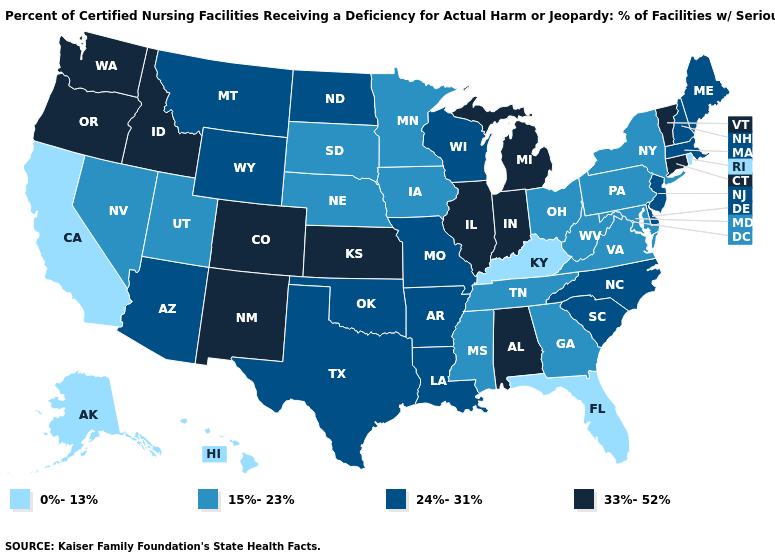What is the highest value in the South ?
Write a very short answer. 33%-52%. Name the states that have a value in the range 15%-23%?
Concise answer only. Georgia, Iowa, Maryland, Minnesota, Mississippi, Nebraska, Nevada, New York, Ohio, Pennsylvania, South Dakota, Tennessee, Utah, Virginia, West Virginia. Name the states that have a value in the range 24%-31%?
Give a very brief answer. Arizona, Arkansas, Delaware, Louisiana, Maine, Massachusetts, Missouri, Montana, New Hampshire, New Jersey, North Carolina, North Dakota, Oklahoma, South Carolina, Texas, Wisconsin, Wyoming. Among the states that border Wyoming , does Idaho have the lowest value?
Give a very brief answer. No. Among the states that border Delaware , does Pennsylvania have the highest value?
Concise answer only. No. What is the highest value in the MidWest ?
Short answer required. 33%-52%. What is the value of Washington?
Answer briefly. 33%-52%. What is the value of New Jersey?
Answer briefly. 24%-31%. What is the value of Kansas?
Concise answer only. 33%-52%. Among the states that border Indiana , does Illinois have the highest value?
Answer briefly. Yes. Does Kentucky have the lowest value in the USA?
Keep it brief. Yes. What is the highest value in states that border Minnesota?
Concise answer only. 24%-31%. What is the lowest value in states that border Utah?
Quick response, please. 15%-23%. Which states have the lowest value in the West?
Keep it brief. Alaska, California, Hawaii. 